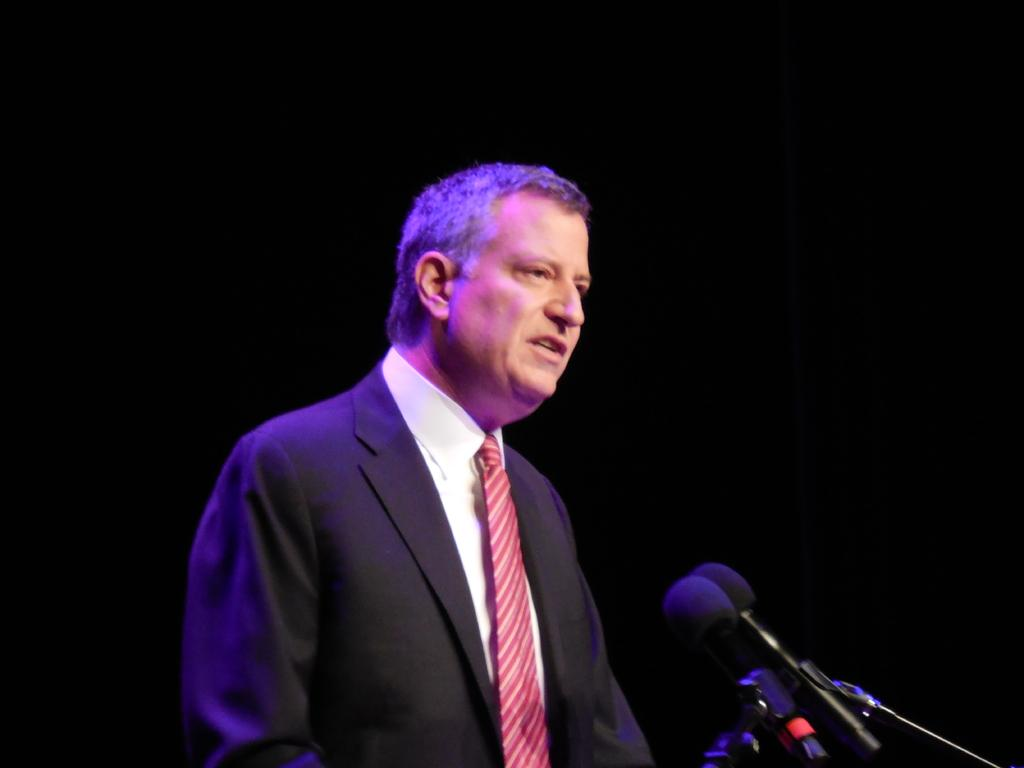What is the main subject of the image? There is a person standing in the middle of the image. What objects are in front of the person? There are microphones in front of the person. Can you see any fowl or seashore in the image? No, there are no fowl or seashore present in the image. Is there a needle visible in the image? No, there is no needle visible in the image. 